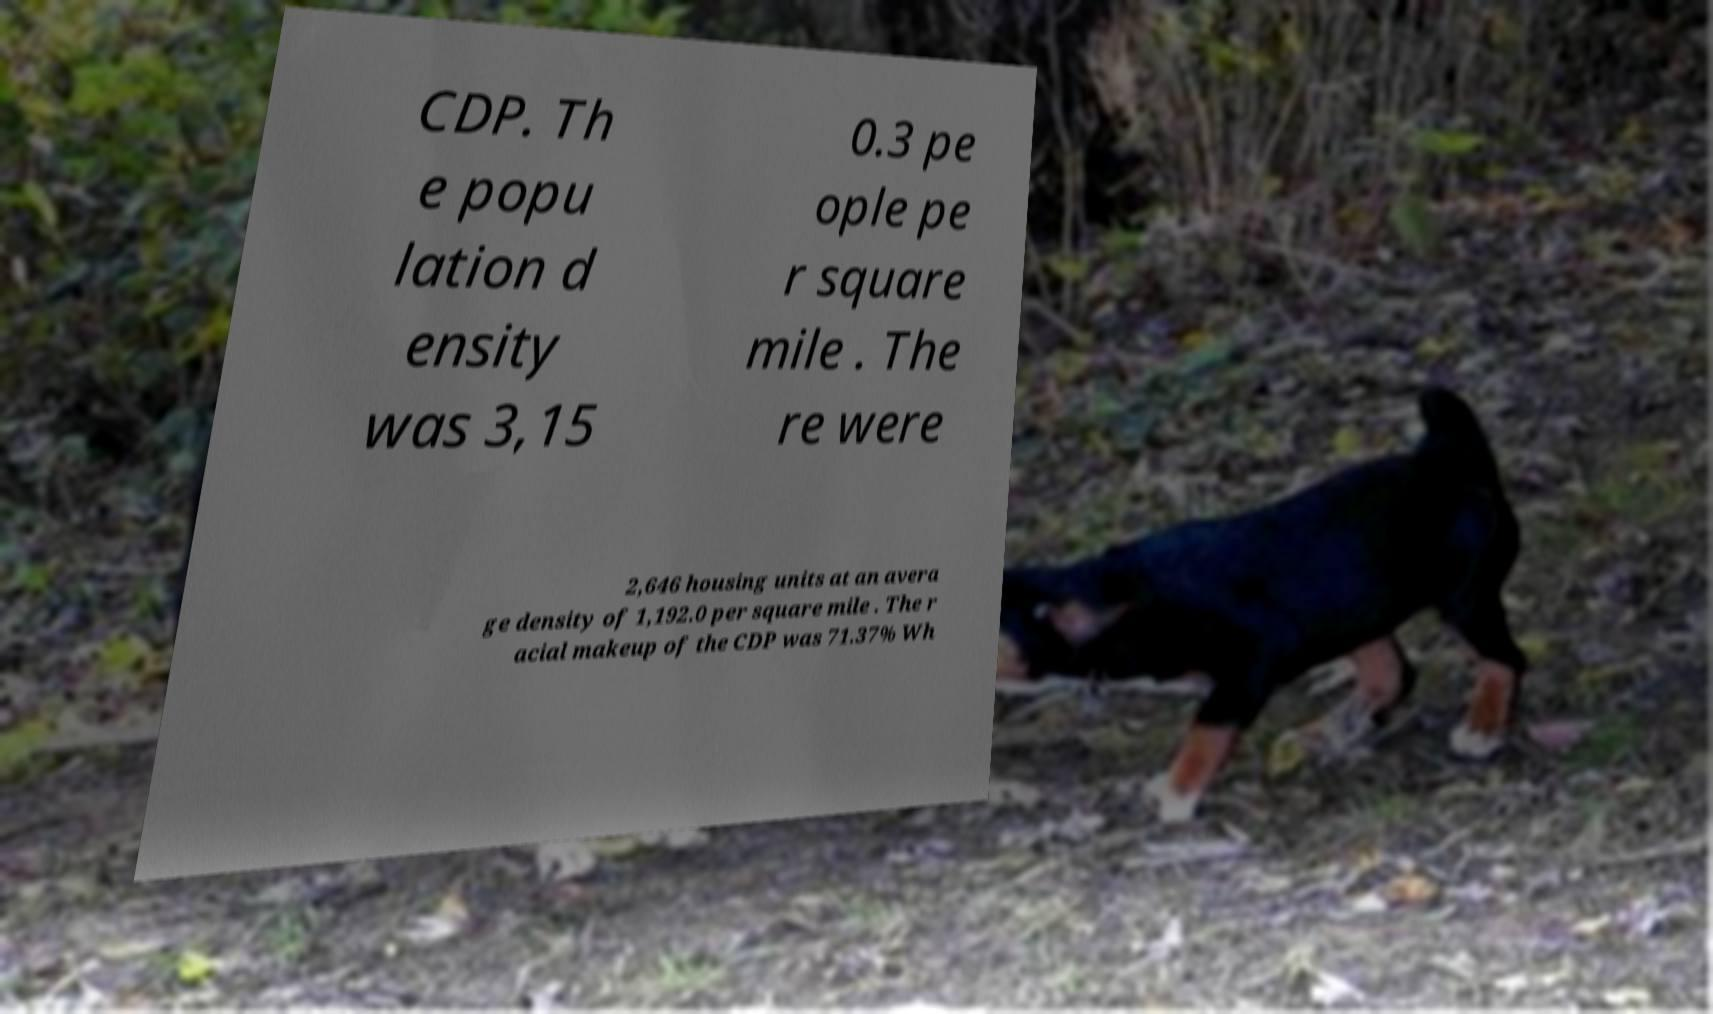Can you read and provide the text displayed in the image?This photo seems to have some interesting text. Can you extract and type it out for me? CDP. Th e popu lation d ensity was 3,15 0.3 pe ople pe r square mile . The re were 2,646 housing units at an avera ge density of 1,192.0 per square mile . The r acial makeup of the CDP was 71.37% Wh 